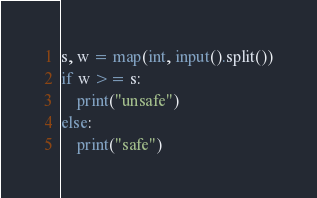Convert code to text. <code><loc_0><loc_0><loc_500><loc_500><_Python_>s, w = map(int, input().split())
if w >= s:
    print("unsafe")
else:
    print("safe")
</code> 